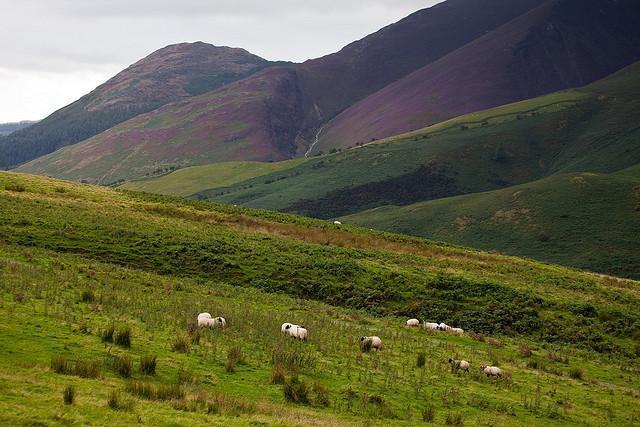How many floor tiles with any part of a cat on them are in the picture?
Give a very brief answer. 0. 